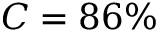<formula> <loc_0><loc_0><loc_500><loc_500>C = 8 6 \%</formula> 